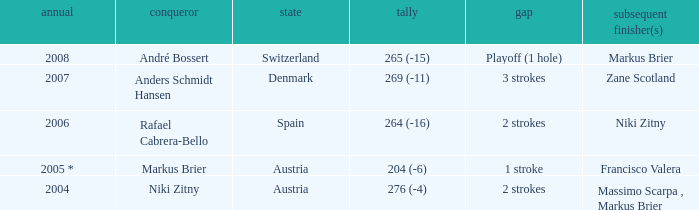What was the score in the year 2004? 276 (-4). 